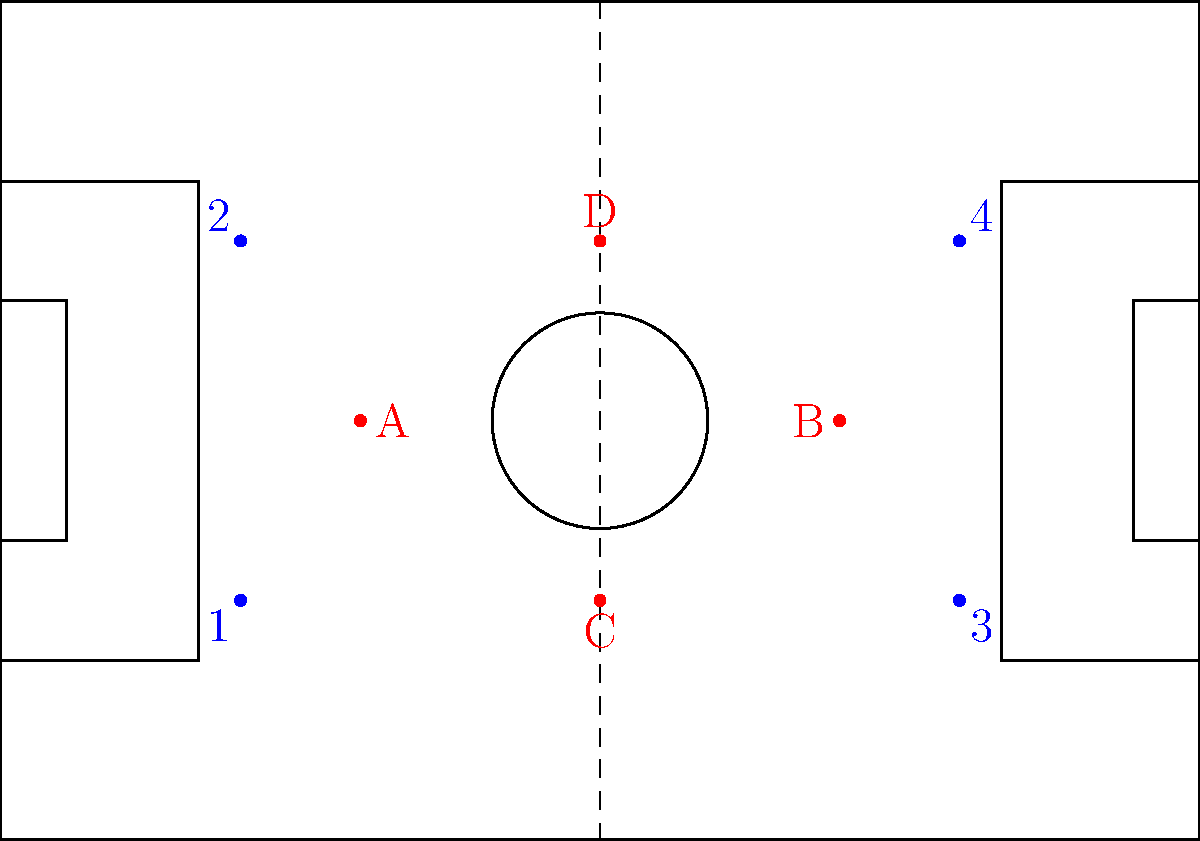As a seasoned football coach, analyze the formation shown in the diagram. The red dots (A, B, C, D) represent your team's players, while the blue dots (1, 2, 3, 4) represent the opposition. What tactical adjustment would you recommend to create a numerical advantage in the midfield area? To analyze this situation and provide a tactical adjustment, let's follow these steps:

1. Current formation analysis:
   - Our team (red dots) appears to be in a diamond formation (4-4-2 diamond).
   - The opposition (blue dots) seems to be in a 4-2-2-2 or 4-2-4 formation.

2. Midfield situation:
   - We have 3 midfielders (A, B, and C) against the opposition's 2 central midfielders.
   - However, the opposition's wide players (1 and 4) can potentially drop into midfield, creating a 4v3 situation against us.

3. Tactical objective:
   - To create a numerical advantage in midfield, we need to outnumber the opposition in this area.

4. Possible adjustment:
   - Instruct player D (likely a striker) to drop deeper into the midfield when defending.
   - This movement would create a 4v2 or 4v4 situation in midfield, depending on the opposition's wide players' positions.

5. Benefits of this adjustment:
   - Increased pressure on opposition midfielders.
   - Better passing options for our team when in possession.
   - Potential to overload the midfield and control the game's tempo.

6. Considerations:
   - This adjustment might leave us with only one striker up front.
   - We'd need to ensure quick transitions to attack when regaining possession.

By implementing this tactical change, we can create a numerical advantage in midfield, allowing for better control of the game and potentially exploiting spaces left by the opposition.
Answer: Instruct player D to drop into midfield, creating a 4v2 or 4v4 situation. 